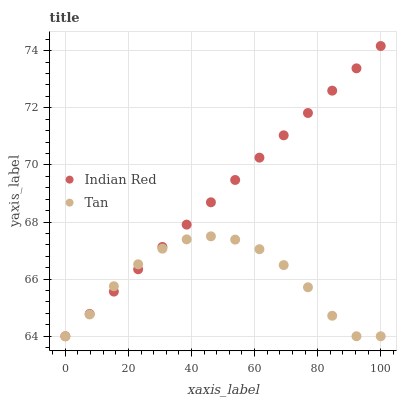Does Tan have the minimum area under the curve?
Answer yes or no. Yes. Does Indian Red have the maximum area under the curve?
Answer yes or no. Yes. Does Indian Red have the minimum area under the curve?
Answer yes or no. No. Is Indian Red the smoothest?
Answer yes or no. Yes. Is Tan the roughest?
Answer yes or no. Yes. Is Indian Red the roughest?
Answer yes or no. No. Does Tan have the lowest value?
Answer yes or no. Yes. Does Indian Red have the highest value?
Answer yes or no. Yes. Does Tan intersect Indian Red?
Answer yes or no. Yes. Is Tan less than Indian Red?
Answer yes or no. No. Is Tan greater than Indian Red?
Answer yes or no. No. 